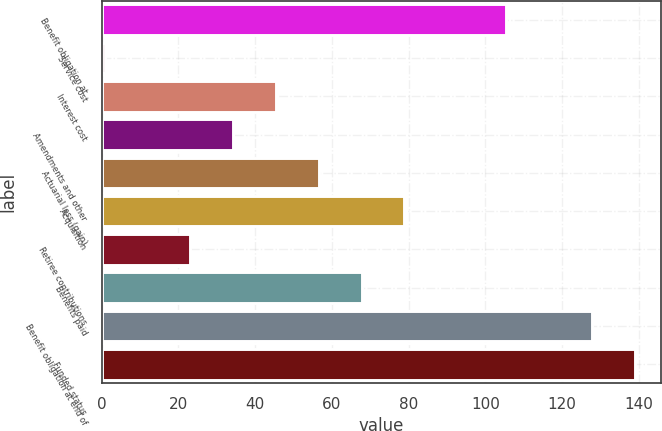<chart> <loc_0><loc_0><loc_500><loc_500><bar_chart><fcel>Benefit obligation at<fcel>Service cost<fcel>Interest cost<fcel>Amendments and other<fcel>Actuarial loss (gain)<fcel>Acquisition<fcel>Retiree contributions<fcel>Benefits paid<fcel>Benefit obligation at end of<fcel>Funded status<nl><fcel>105.5<fcel>0.9<fcel>45.46<fcel>34.32<fcel>56.6<fcel>78.88<fcel>23.18<fcel>67.74<fcel>127.78<fcel>138.92<nl></chart> 